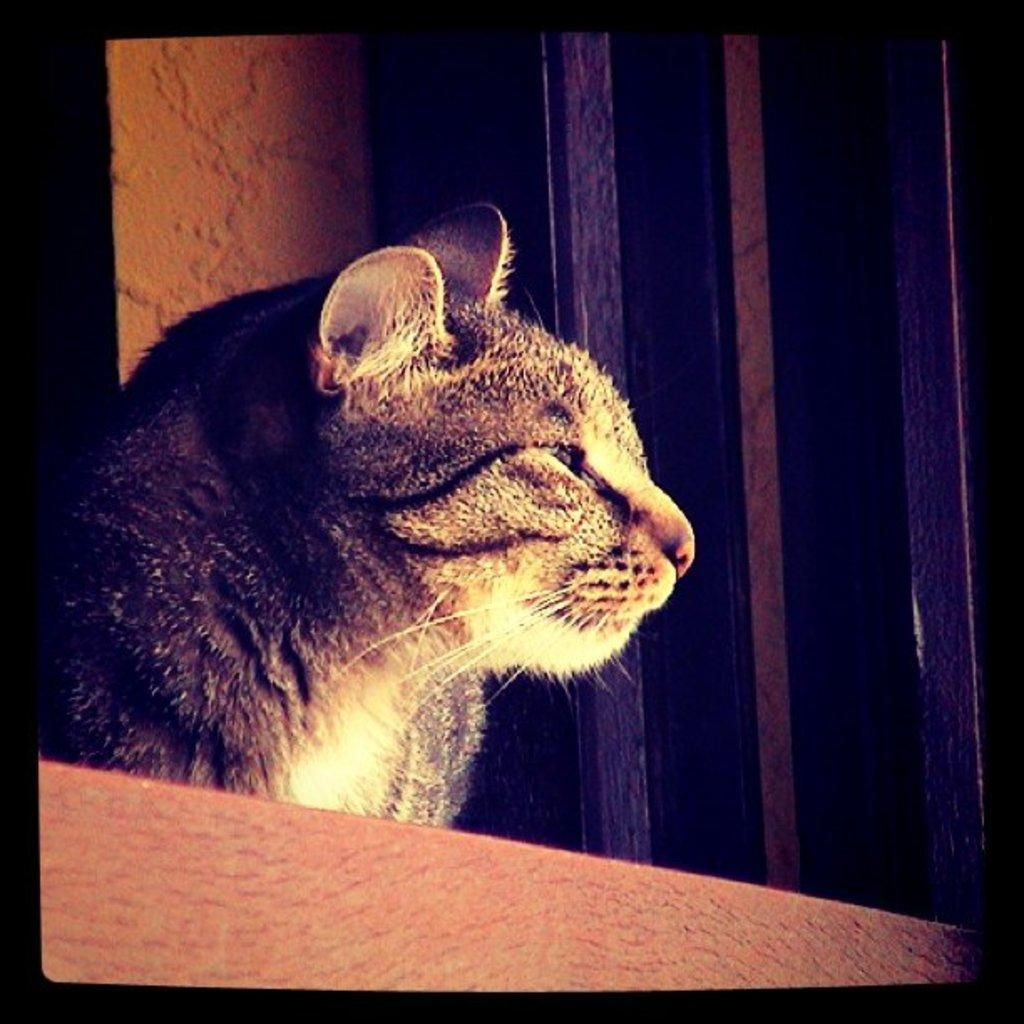What animal is in the foreground of the image? There is a cat in the foreground of the image. What can be seen in the background of the image? There appears to be a window in the background of the image. What nation is being discussed by the cat in the image? There is no indication in the image that the cat is discussing any nation, as cats do not engage in discussions. 